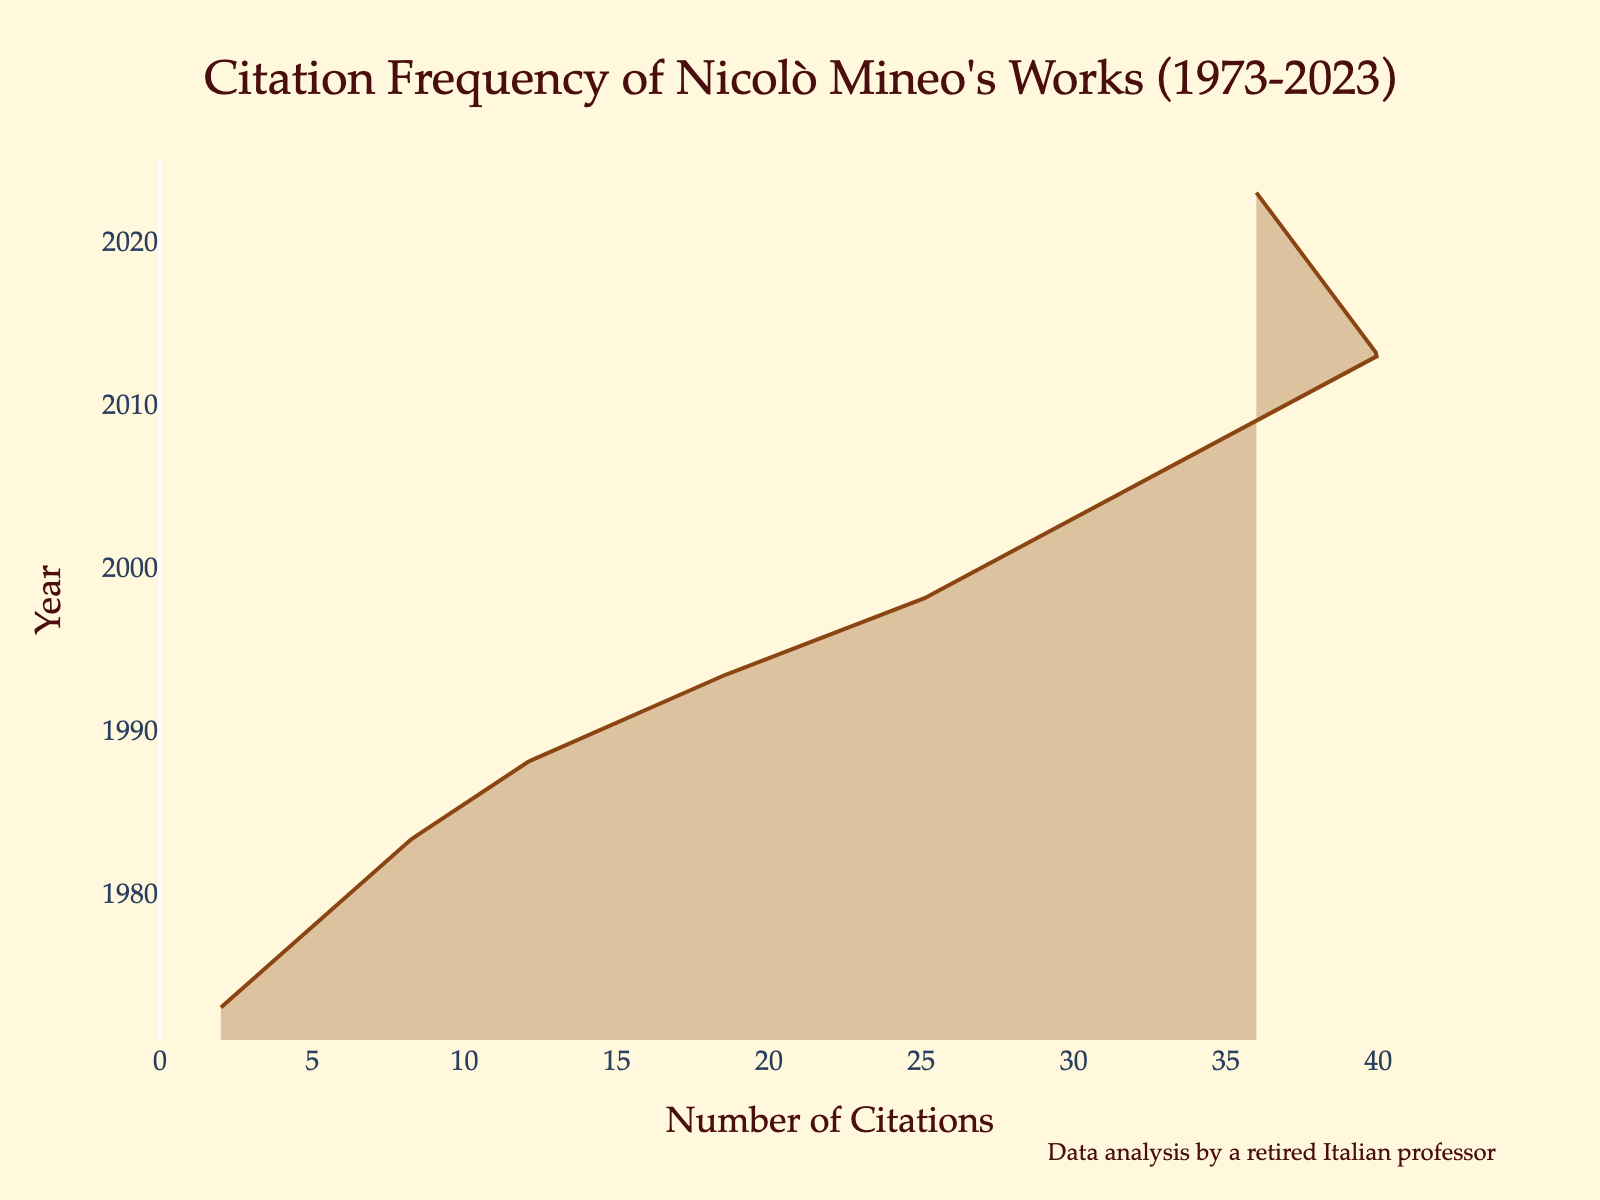What is the title of the plot? The title of the plot is found at the top and is typically the largest text on the figure. It gives a summary of what the plot is about. The title here is "Citation Frequency of Nicolò Mineo's Works (1973-2023)."
Answer: Citation Frequency of Nicolò Mineo's Works (1973-2023) What does the x-axis represent? The x-axis typically represents the primary variable for analysis in horizontal line plots. In this figure, it represents the number of citations.
Answer: Number of Citations In which year did Nicolò Mineo receive the most citations? By looking at the peak or highest point of the density plot on the y-axis, we can identify the year with the most citations; this is around the year 2013.
Answer: 2013 How many citations are there in the year with the maximum frequency? The maximum frequency corresponds to the peak of the density curve in the plot; this is noted with approximately 40 citations in 2013.
Answer: 40 What is the range of years considered in this plot? The plot uses data on the y-axis to display the years from the minimum to the maximum range, starting at 1973 up to 2023.
Answer: 1973 to 2023 Compare the number of citations in 1993 and 2023. By comparing the heights of the density curve along the y-axis for 1993 and 2023, it shows that 1993 has about 18 citations whereas 2023 has around 36 citations.
Answer: 1993 has 18 citations, 2023 has 36 citations What is the trend in citation frequency from 1973 to 2003? Observing the density plot from 1973 to 2003, there is a consistent upward trend in citation frequency, reflecting a gradual increase over time.
Answer: Upward trend Which decade saw the largest increase in citation frequency? By analyzing the increments in citation frequency in each decade, the decade from 1993 to 2003 shows the most significant increase, from 18 to 30 citations.
Answer: 1993 to 2003 Is the citation frequency higher in 2018 or 2023? Comparing the number of citations in 2018 and 2023, the plot shows that 2018 has 38 citations while 2023 has 36 citations, making 2018 higher.
Answer: 2018 What is the average number of citations from 1973 to 2023? To find this, we add the number of citations from each year and divide by the total number of years: (2 + 5 + 8 + 12 + 18 + 25 + 30 + 35 + 40 + 38 + 36) / 11 = 22.55 citations on average.
Answer: 22.55 